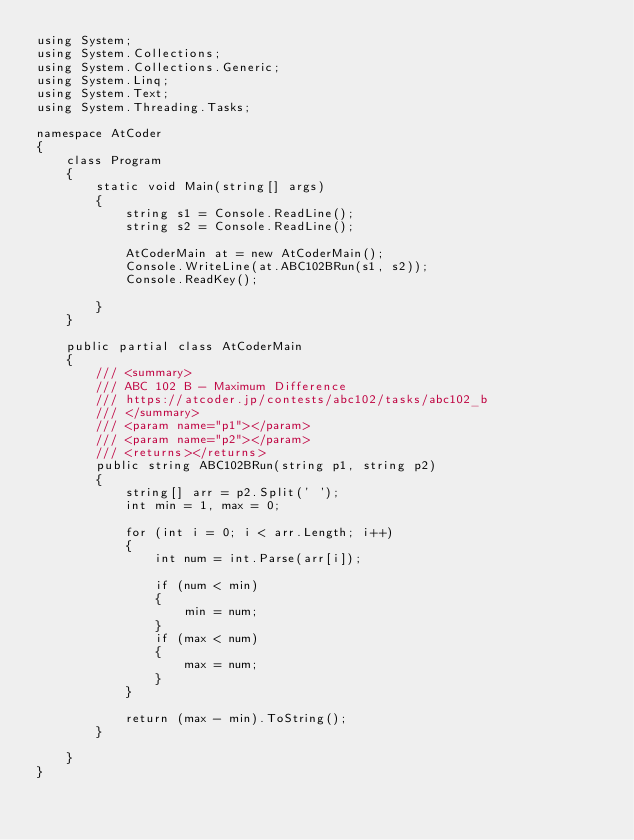Convert code to text. <code><loc_0><loc_0><loc_500><loc_500><_C#_>using System;
using System.Collections;
using System.Collections.Generic;
using System.Linq;
using System.Text;
using System.Threading.Tasks;

namespace AtCoder
{
    class Program
    {
        static void Main(string[] args)
        {
            string s1 = Console.ReadLine();
            string s2 = Console.ReadLine();

            AtCoderMain at = new AtCoderMain();
            Console.WriteLine(at.ABC102BRun(s1, s2));
            Console.ReadKey();

        }
    }

    public partial class AtCoderMain
    {
        /// <summary>
        /// ABC 102 B - Maximum Difference
        /// https://atcoder.jp/contests/abc102/tasks/abc102_b
        /// </summary>
        /// <param name="p1"></param>
        /// <param name="p2"></param>
        /// <returns></returns>
        public string ABC102BRun(string p1, string p2)
        {
            string[] arr = p2.Split(' ');
            int min = 1, max = 0;

            for (int i = 0; i < arr.Length; i++)
            {
                int num = int.Parse(arr[i]);

                if (num < min)
                {
                    min = num;
                }
                if (max < num)
                {
                    max = num;
                }
            }

            return (max - min).ToString();
        }

    }
}
</code> 